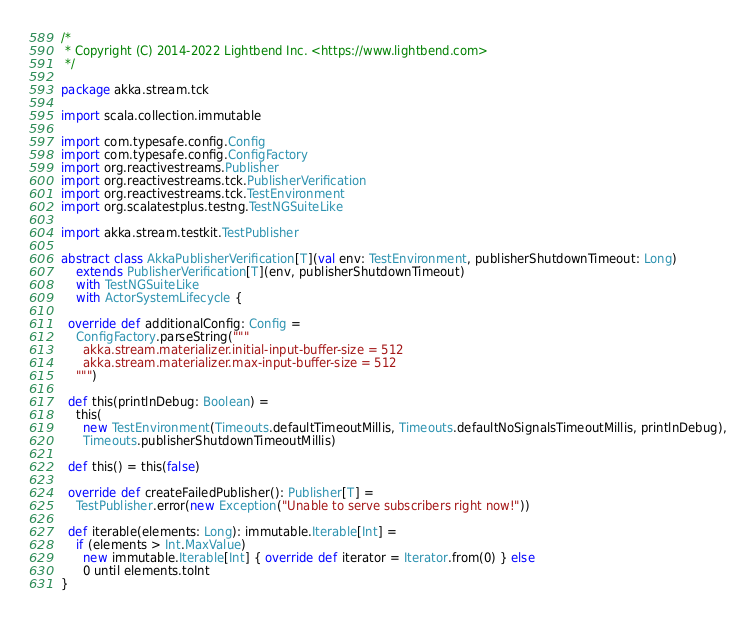Convert code to text. <code><loc_0><loc_0><loc_500><loc_500><_Scala_>/*
 * Copyright (C) 2014-2022 Lightbend Inc. <https://www.lightbend.com>
 */

package akka.stream.tck

import scala.collection.immutable

import com.typesafe.config.Config
import com.typesafe.config.ConfigFactory
import org.reactivestreams.Publisher
import org.reactivestreams.tck.PublisherVerification
import org.reactivestreams.tck.TestEnvironment
import org.scalatestplus.testng.TestNGSuiteLike

import akka.stream.testkit.TestPublisher

abstract class AkkaPublisherVerification[T](val env: TestEnvironment, publisherShutdownTimeout: Long)
    extends PublisherVerification[T](env, publisherShutdownTimeout)
    with TestNGSuiteLike
    with ActorSystemLifecycle {

  override def additionalConfig: Config =
    ConfigFactory.parseString("""
      akka.stream.materializer.initial-input-buffer-size = 512
      akka.stream.materializer.max-input-buffer-size = 512
    """)

  def this(printlnDebug: Boolean) =
    this(
      new TestEnvironment(Timeouts.defaultTimeoutMillis, Timeouts.defaultNoSignalsTimeoutMillis, printlnDebug),
      Timeouts.publisherShutdownTimeoutMillis)

  def this() = this(false)

  override def createFailedPublisher(): Publisher[T] =
    TestPublisher.error(new Exception("Unable to serve subscribers right now!"))

  def iterable(elements: Long): immutable.Iterable[Int] =
    if (elements > Int.MaxValue)
      new immutable.Iterable[Int] { override def iterator = Iterator.from(0) } else
      0 until elements.toInt
}
</code> 